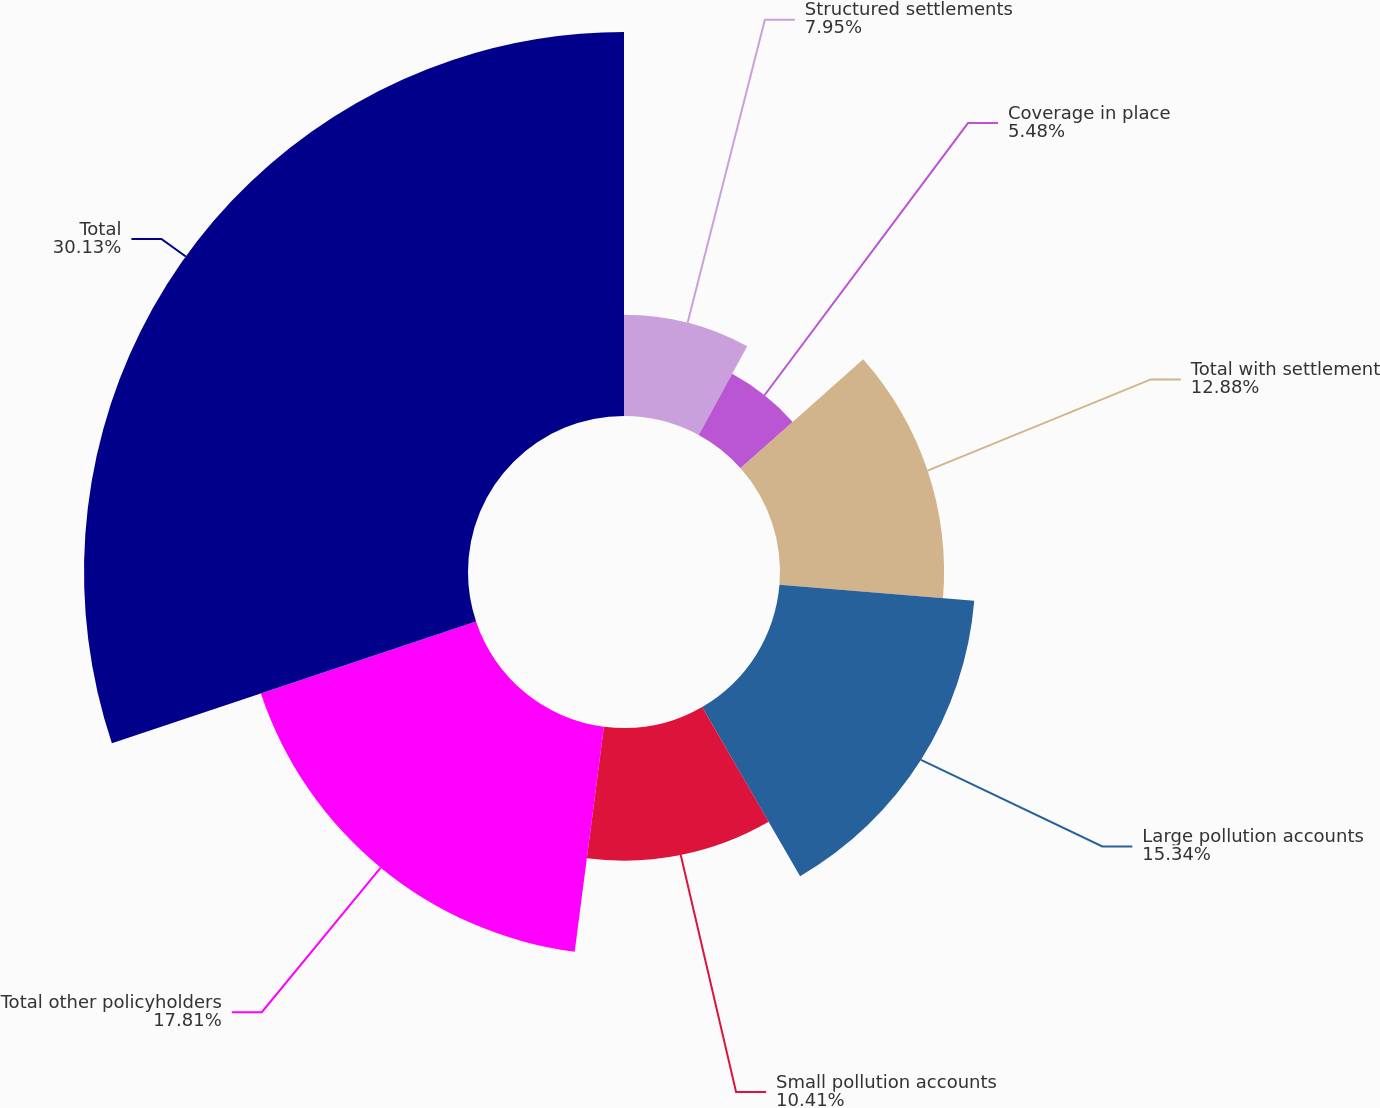Convert chart. <chart><loc_0><loc_0><loc_500><loc_500><pie_chart><fcel>Structured settlements<fcel>Coverage in place<fcel>Total with settlement<fcel>Large pollution accounts<fcel>Small pollution accounts<fcel>Total other policyholders<fcel>Total<nl><fcel>7.95%<fcel>5.48%<fcel>12.88%<fcel>15.34%<fcel>10.41%<fcel>17.81%<fcel>30.14%<nl></chart> 